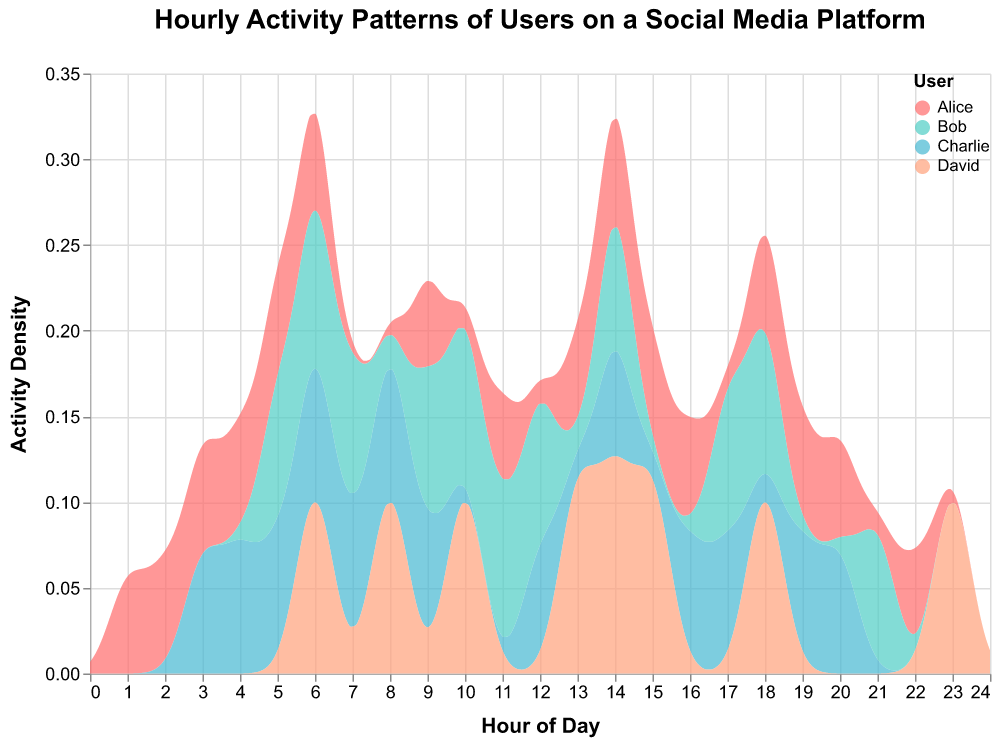What is the title of the figure? The title of the figure is prominently displayed at the top and provides the overall theme or subject of the plot.
Answer: Hourly Activity Patterns of Users on a Social Media Platform Which user seems to have the highest activity density? By examining the peaks in the density plot, we can identify which user's curve reaches the highest density value.
Answer: Alice At what hour does Charlie have a noticeable peak in activity? By observing the x-axis (Hour of Day) and following Charlie's color-coded density curve, we can locate the hour where the peak occurs.
Answer: 6 AM How does Bob's activity density compare to Alice's density at 9 AM? By comparing the height of the density curves for Bob and Alice at the 9 AM mark, we can see which one is higher. Alice's density is higher at this point.
Answer: Alice's density is higher During which hours is David's activity density significantly high? The density plot for David will show peaks at specific hours. We need to look for these peaks across the 24-hour span.
Answer: 6 AM, 10 AM, 14 PM, 18 PM Which user shows the most consistent activity throughout the day? A user with a relatively flat or uniformly distributed density curve indicates consistent activity.
Answer: Charlie What is the general trend of Alice's activity throughout the day? By examining Alice's density plot, we can observe the rise and fall of her activity levels across different hours.
Answer: Peaks in early morning, then gradually decreases Is there any hour where all users have a noticeable activity density? We look for hours with overlapping high-density regions across all user curves. The shared hour where most users are active stands out.
Answer: 6 AM How does Bob's activity density at 11 AM compare to his activity at 7 AM? By comparing the heights of Bob's density curves at 7 AM and 11 AM, we can determine if activity has increased or decreased. It increases at 11 AM compared to 7 AM.
Answer: Increased In the early morning hours (midnight to 6 AM), which user is most active? By focusing on the first six hours of the density plot and comparing the users' curves, we can identify the most prominent one.
Answer: Alice 